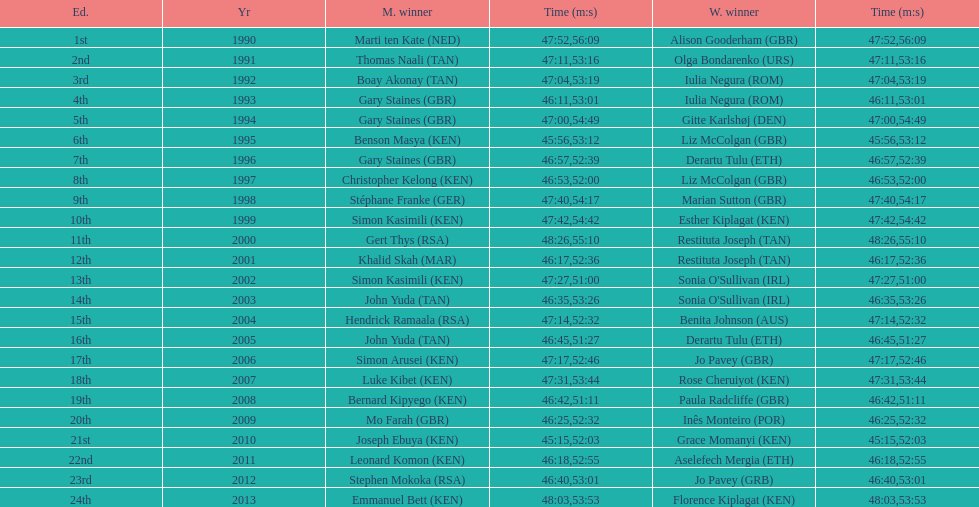Home many times did a single country win both the men's and women's bupa great south run? 4. 